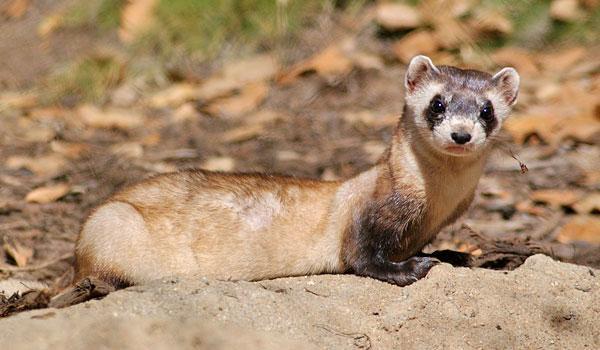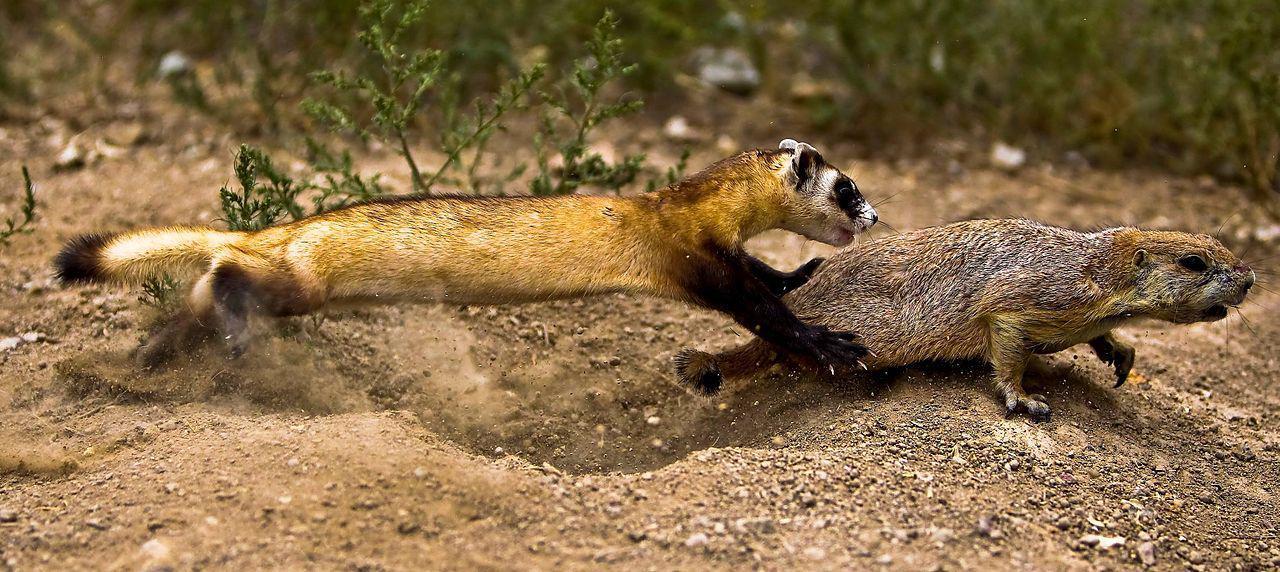The first image is the image on the left, the second image is the image on the right. Examine the images to the left and right. Is the description "One image shows a ferret with raised head, and body turned to the left." accurate? Answer yes or no. No. The first image is the image on the left, the second image is the image on the right. Examine the images to the left and right. Is the description "All bodies of the animals pictured are facing right." accurate? Answer yes or no. Yes. 